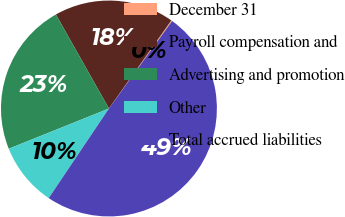Convert chart. <chart><loc_0><loc_0><loc_500><loc_500><pie_chart><fcel>December 31<fcel>Payroll compensation and<fcel>Advertising and promotion<fcel>Other<fcel>Total accrued liabilities<nl><fcel>0.15%<fcel>17.98%<fcel>22.91%<fcel>9.5%<fcel>49.46%<nl></chart> 